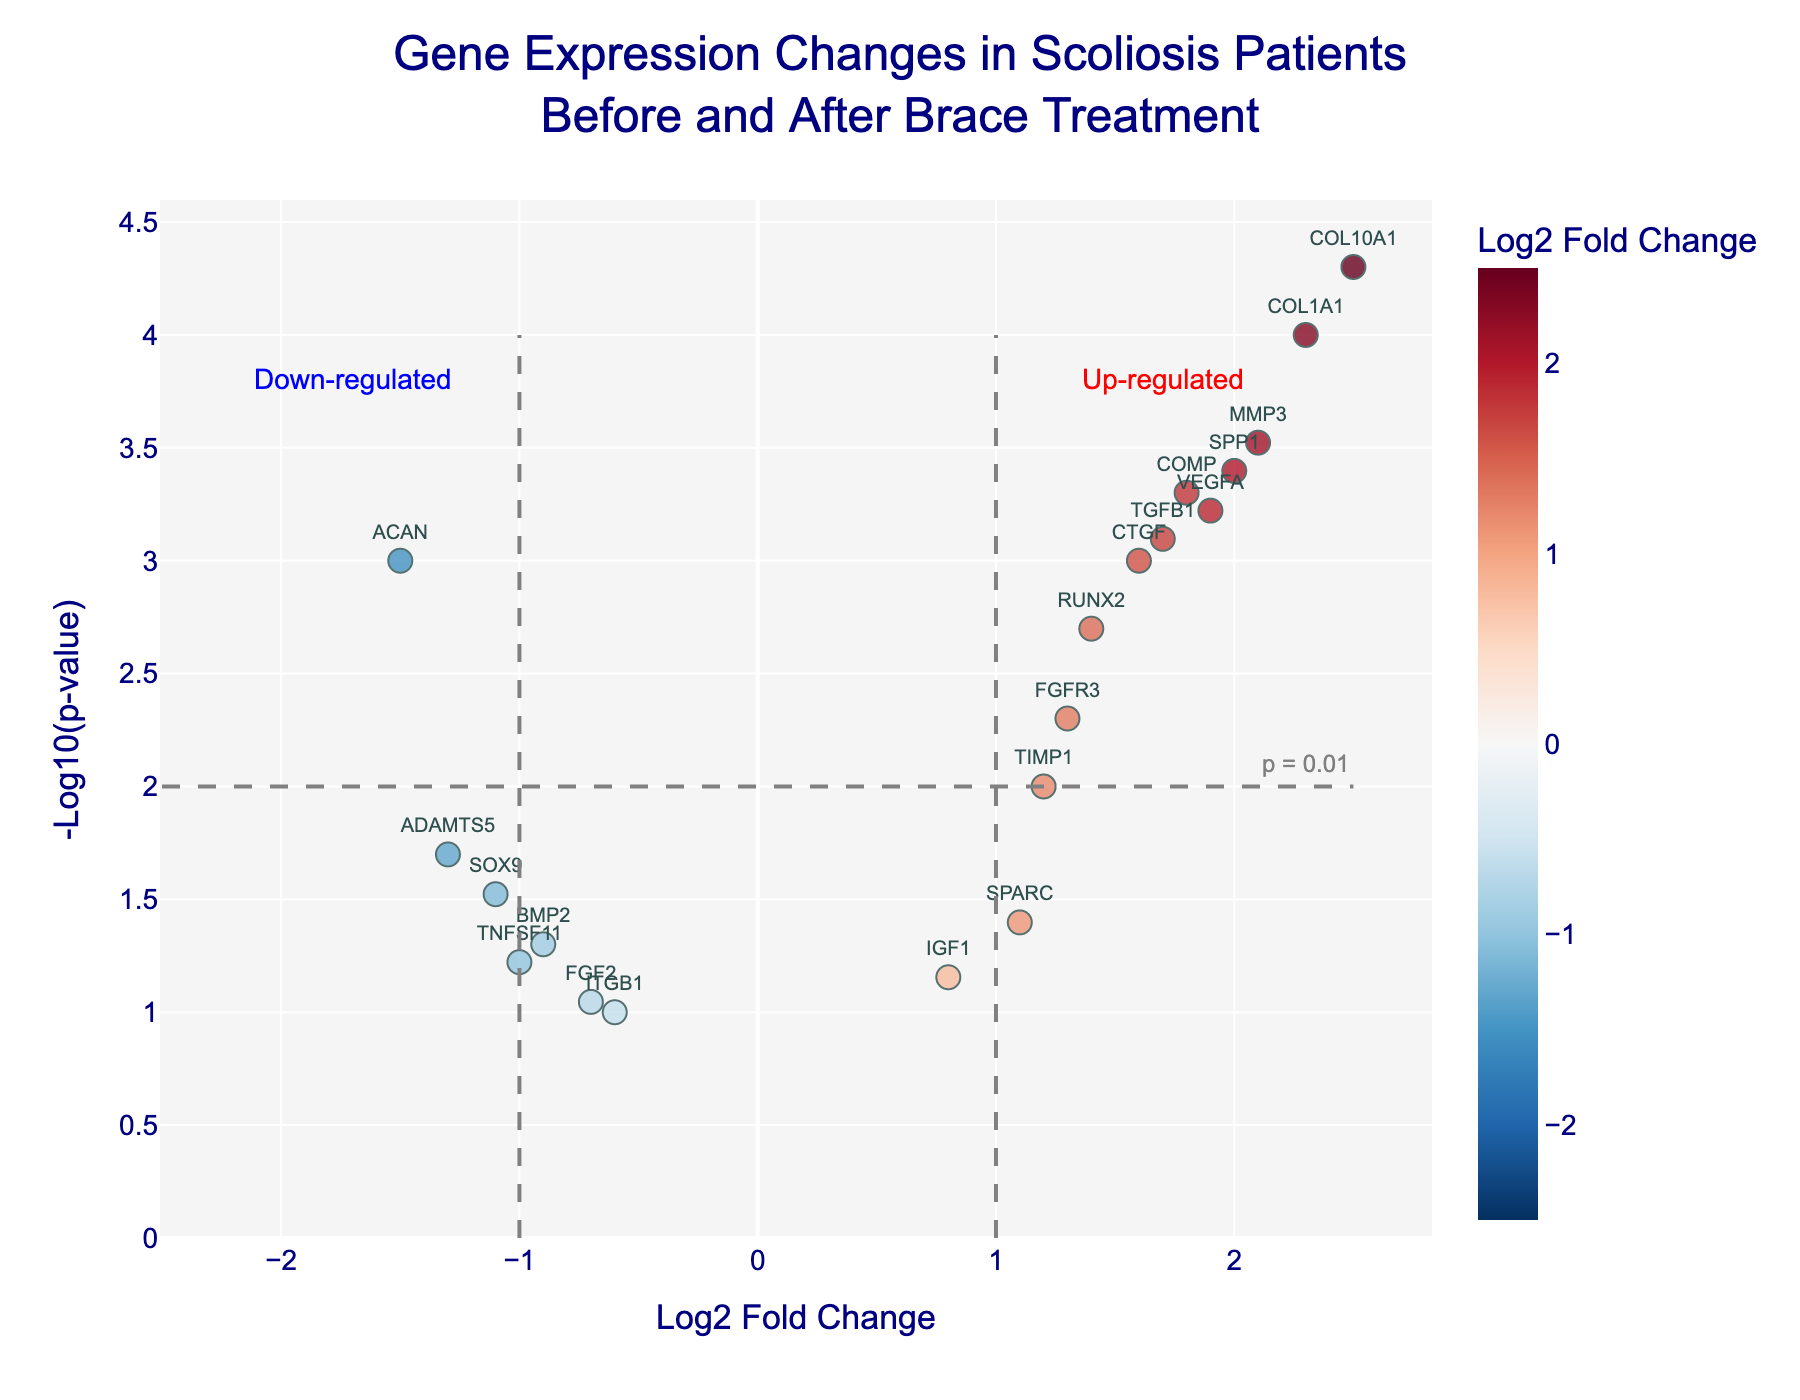How many genes show a significant change in expression with a p-value less than 0.05? To find the number of genes with a p-value less than 0.05, we count the points that are above the threshold line at y = -log10(0.05).
Answer: 15 What is the title of the figure? The title is located at the top of the figure, usually in a prominent font. The title of the plot is "Gene Expression Changes in Scoliosis Patients Before and After Brace Treatment".
Answer: Gene Expression Changes in Scoliosis Patients Before and After Brace Treatment Which gene has the highest log2 fold change in expression? The gene with the highest log2 fold change is found by identifying the farthest point to the right on the x-axis. The gene is COL10A1 with a log2 fold change of 2.5.
Answer: COL10A1 What are the colors used to represent the log2 fold change values? The color scale on the plot, which typically ranges from blue to red, indicates the log2 fold change values. Blue represents lower values, while red represents higher values.
Answer: Blue to Red How many genes are identified in the plot? To determine the total number of genes, count the individual points on the plot. There are 20 different genes plotted.
Answer: 20 Compare the p-values of COL1A1 and ACAN. Which gene has a more significant change in expression? By comparing their positions on the y-axis, we see that COL1A1 has a higher -log10(p-value) than ACAN, indicating a more significant change.
Answer: COL1A1 Are there more up-regulated or down-regulated genes? To answer this, count the number of genes on the right side (positive log2 fold change, up-regulated) and the left side (negative log2 fold change, down-regulated) of the x-axis. There are 13 up-regulated and 7 down-regulated genes.
Answer: Up-regulated What does the -log10(p-value) signify in the context of this plot? The -log10(p-value) represents the significance of the gene expression changes. Higher values of -log10(p-value) indicate more significant changes.
Answer: Significance of change Which genes are most likely to be discussed for clinical relevance based on their position on the plot? Genes that are both high in fold change and have high significance (-log10(p-value)) are likely to be clinically relevant. These include COL10A1, COL1A1, and SPP1.
Answer: COL10A1, COL1A1, SPP1 What fold change threshold appears to be used to distinguish between significant up-regulation and down-regulation? The vertical dashed lines at x = 1 and x = -1 serve as thresholds. Genes beyond these lines are considered significantly up-regulated or down-regulated.
Answer: 1 and -1 